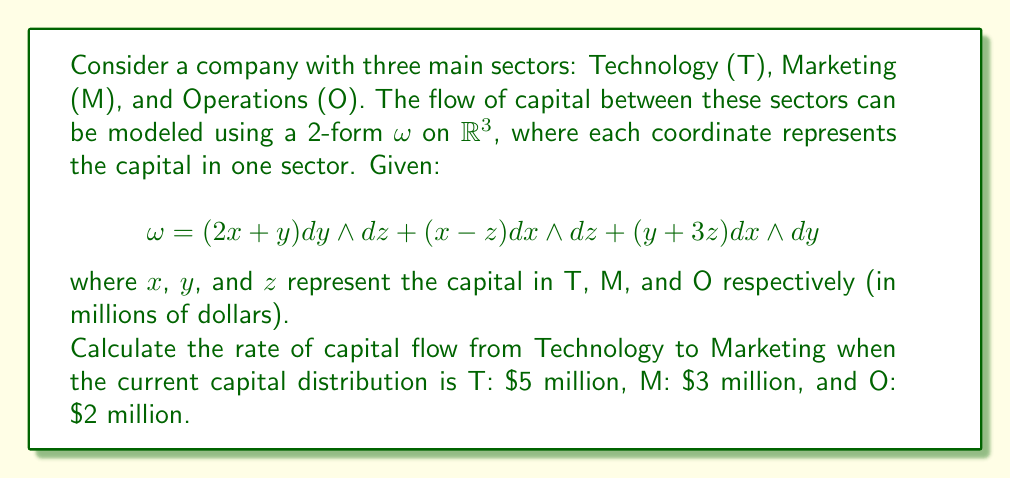Could you help me with this problem? To solve this problem, we need to follow these steps:

1) The 2-form $\omega$ represents the flow of capital between sectors. The coefficient of $dy \wedge dz$ represents the flow from T to M.

2) From the given 2-form:
   $$\omega = (2x + y) dy \wedge dz + \ldots$$
   
   The coefficient we're interested in is $(2x + y)$.

3) To find the rate of flow from T to M, we need to evaluate this coefficient at the given point:
   x = 5 (Technology)
   y = 3 (Marketing)
   z = 2 (Operations)

4) Substituting these values:
   Rate of flow from T to M = $2x + y$
                             = $2(5) + 3$
                             = $10 + 3$
                             = $13$

5) Therefore, the rate of capital flow from Technology to Marketing is $13 million per unit time.

Note: The positive value indicates that capital is flowing from Technology to Marketing. If it were negative, it would indicate flow in the opposite direction.
Answer: $13 million per unit time 